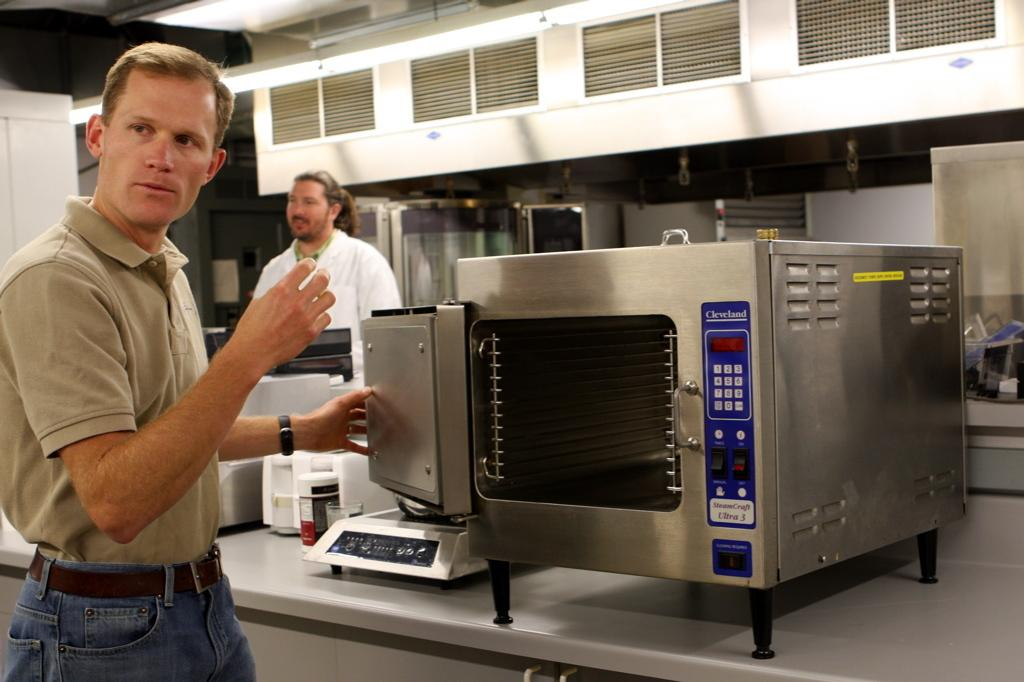How many people are present in the image? There are two people in the image. What kitchen appliances can be seen in the image? There is a microwave oven and an induction stove in the image. Can you describe any other objects in the image? There are some unspecified objects in the image. What type of apparatus is being used by the mice in the image? There are no mice present in the image, and therefore no apparatus being used by them. Can you describe the hook that is hanging from the ceiling in the image? There is no hook hanging from the ceiling in the image. 